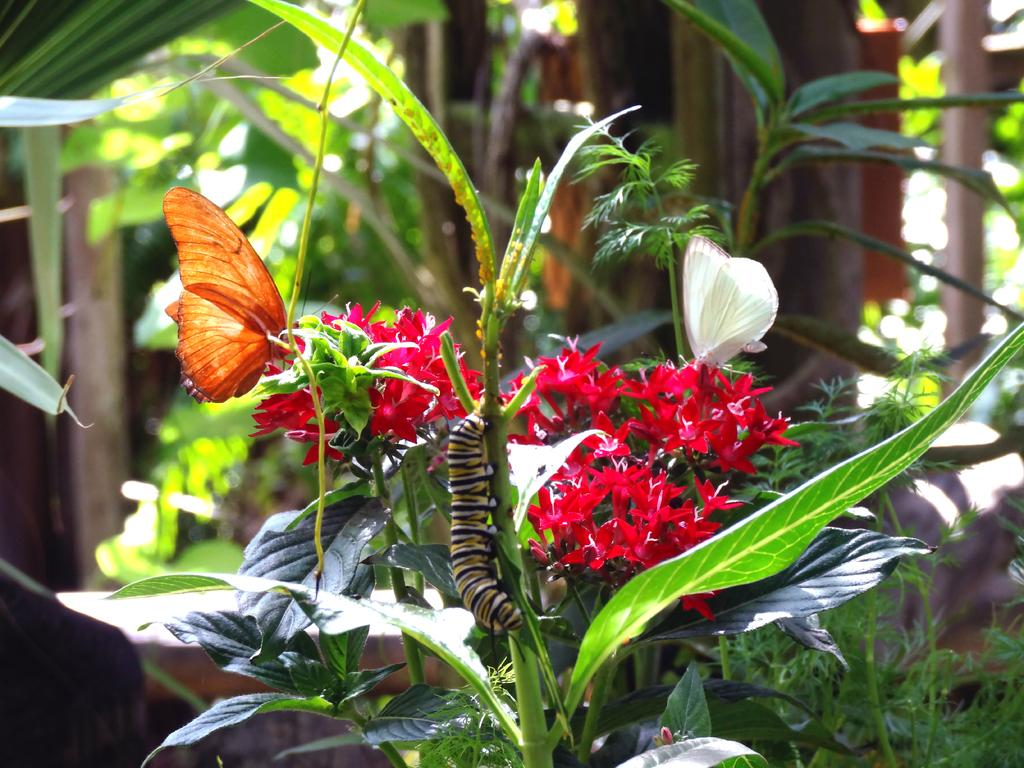What type of insect is on the plant in the image? There is a caterpillar on a plant in the image. What other insects can be seen in the image? There are two butterflies in the image. Where are the butterflies located in the image? The butterflies are on the flowers of a plant. What part of the plant with butterflies is visible in the image? The plant with butterflies has leaves. What else can be seen in the background of the image? There are other plants visible in the background of the image. Can you tell me how many cables are connected to the giraffe in the image? There is no giraffe present in the image, and therefore no cables can be connected to it. 